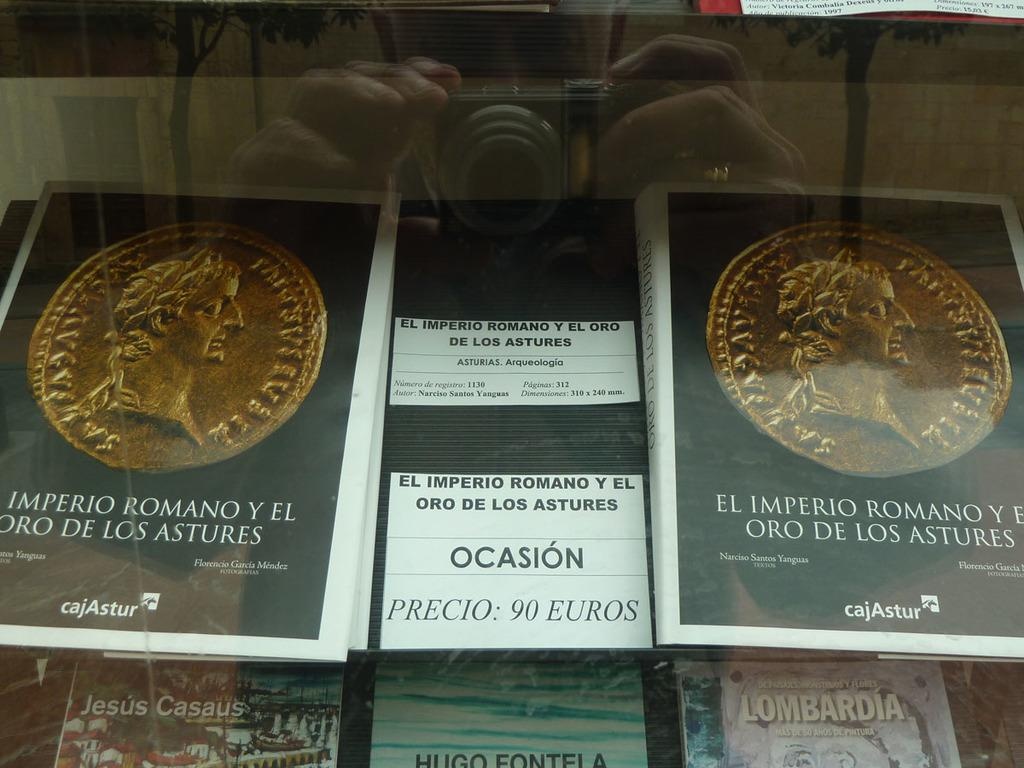<image>
Offer a succinct explanation of the picture presented. A showcasing of El Imperio Romano Oro De Los Astures. 